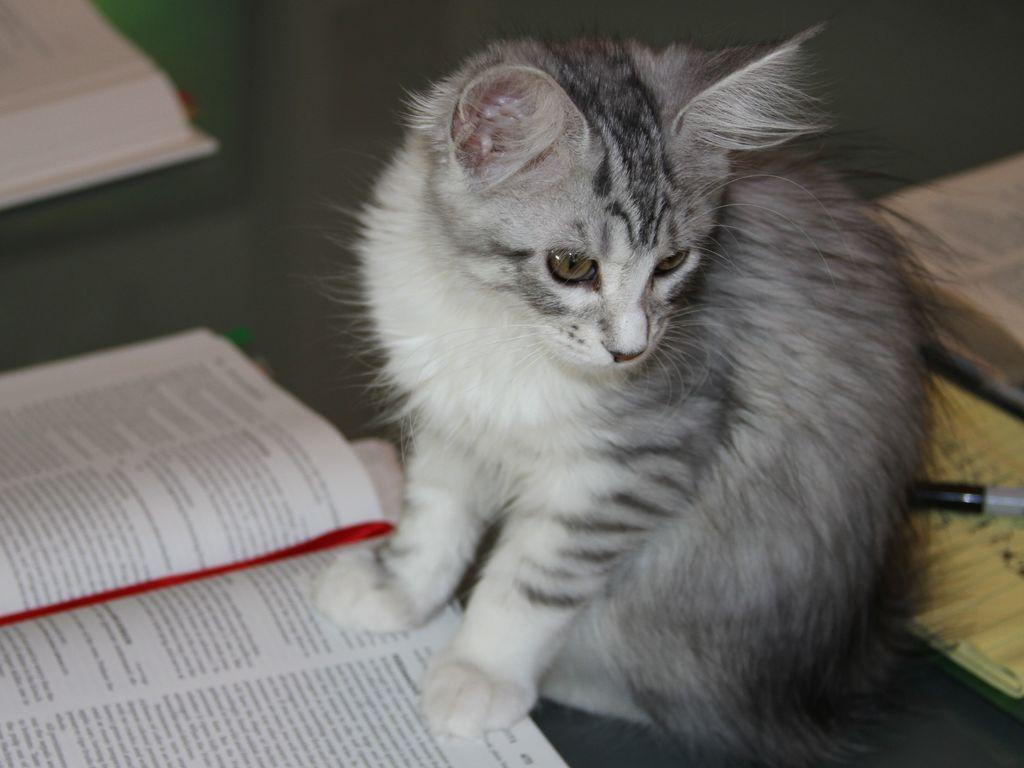What type of animal is in the image? There is a cat in the image. Can you describe the color of the cat? The cat is white and black in color. Where is the cat sitting in the image? The cat is sitting on a black surface. What other items can be seen around the cat? There are books and a pen visible around the cat. What is the cat's profit from the books in the image? There is no indication of profit or any financial aspect in the image. The cat is simply sitting on a black surface surrounded by books and a pen. 